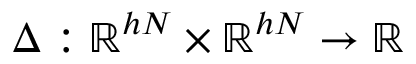Convert formula to latex. <formula><loc_0><loc_0><loc_500><loc_500>\Delta \colon \mathbb { R } ^ { h N } \times \mathbb { R } ^ { h N } \to \mathbb { R }</formula> 